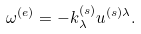<formula> <loc_0><loc_0><loc_500><loc_500>\omega ^ { ( e ) } = - k ^ { ( s ) } _ { \lambda } u ^ { ( s ) \lambda } .</formula> 